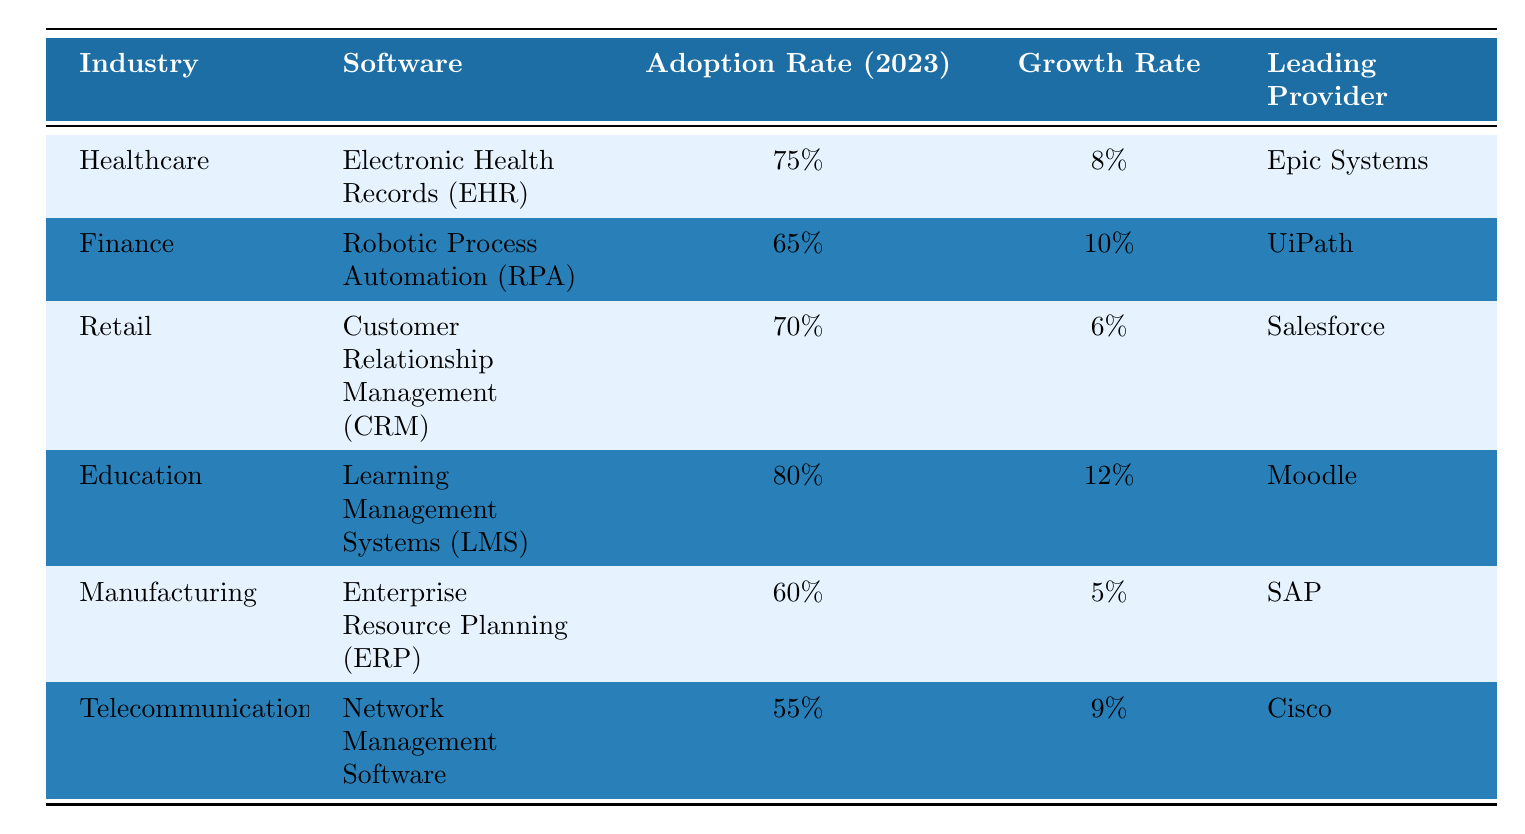What is the adoption rate of Electronic Health Records in the Healthcare industry? The table states that the adoption rate for Electronic Health Records (EHR) in the Healthcare industry is presented directly in the table. Referring to that specific row shows that the adoption rate is 75%.
Answer: 75% Which industry has the highest software adoption rate in 2023? Looking through the adoption rates listed in the table, Education has the highest rate of 80% for Learning Management Systems (LMS).
Answer: Education What is the average adoption rate of software across all the industries listed? To find the average adoption rate, we need to sum the adoption rates: 75 + 65 + 70 + 80 + 60 + 55 = 405. Since there are 6 industries, we divide by 6: 405 / 6 = 67.5.
Answer: 67.5% Is the adoption rate for Robotic Process Automation higher than 70%? The table shows that the adoption rate for Robotic Process Automation (RPA) in the Finance industry is listed as 65%. Therefore, it is not higher than 70%.
Answer: No Which software has the highest growth rate among the listed industries? By examining the growth rates from the table, Learning Management Systems (LMS) in Education has the highest growth rate at 12%.
Answer: Learning Management Systems (LMS) Is there an industry where the leading provider is SAP? Yes, referring to the Manufacturing industry in the table, it specifies that the leading provider of Enterprise Resource Planning (ERP) software is SAP.
Answer: Yes Calculate the difference in adoption rates between the highest and lowest software adoption rates provided. The highest adoption rate is 80% in the Education industry for LMS, and the lowest adoption rate is 55% in Telecommunications for Network Management Software. The difference is 80% - 55% = 25%.
Answer: 25% Which industry has a growth rate of 6%? The Retail industry shows a growth rate of 6% for its Customer Relationship Management (CRM) software as mentioned in the respective row of the table.
Answer: Retail 